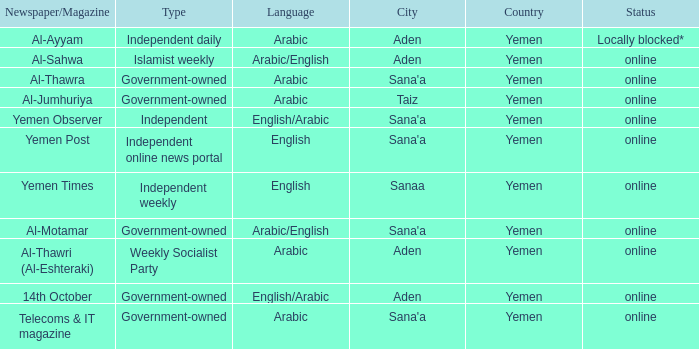What is Headquarter, when Language is English, and when Type is Independent Online News Portal? Sana'a. 